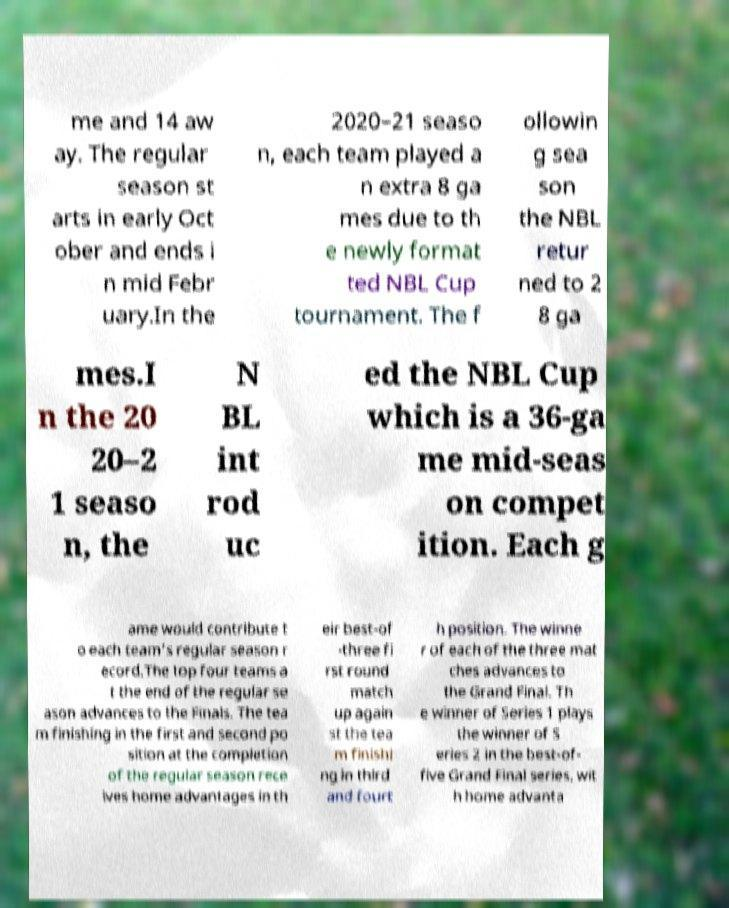I need the written content from this picture converted into text. Can you do that? me and 14 aw ay. The regular season st arts in early Oct ober and ends i n mid Febr uary.In the 2020–21 seaso n, each team played a n extra 8 ga mes due to th e newly format ted NBL Cup tournament. The f ollowin g sea son the NBL retur ned to 2 8 ga mes.I n the 20 20–2 1 seaso n, the N BL int rod uc ed the NBL Cup which is a 36-ga me mid-seas on compet ition. Each g ame would contribute t o each team’s regular season r ecord.The top four teams a t the end of the regular se ason advances to the Finals. The tea m finishing in the first and second po sition at the completion of the regular season rece ives home advantages in th eir best-of -three fi rst round match up again st the tea m finishi ng in third and fourt h position. The winne r of each of the three mat ches advances to the Grand Final. Th e winner of Series 1 plays the winner of S eries 2 in the best-of- five Grand Final series, wit h home advanta 